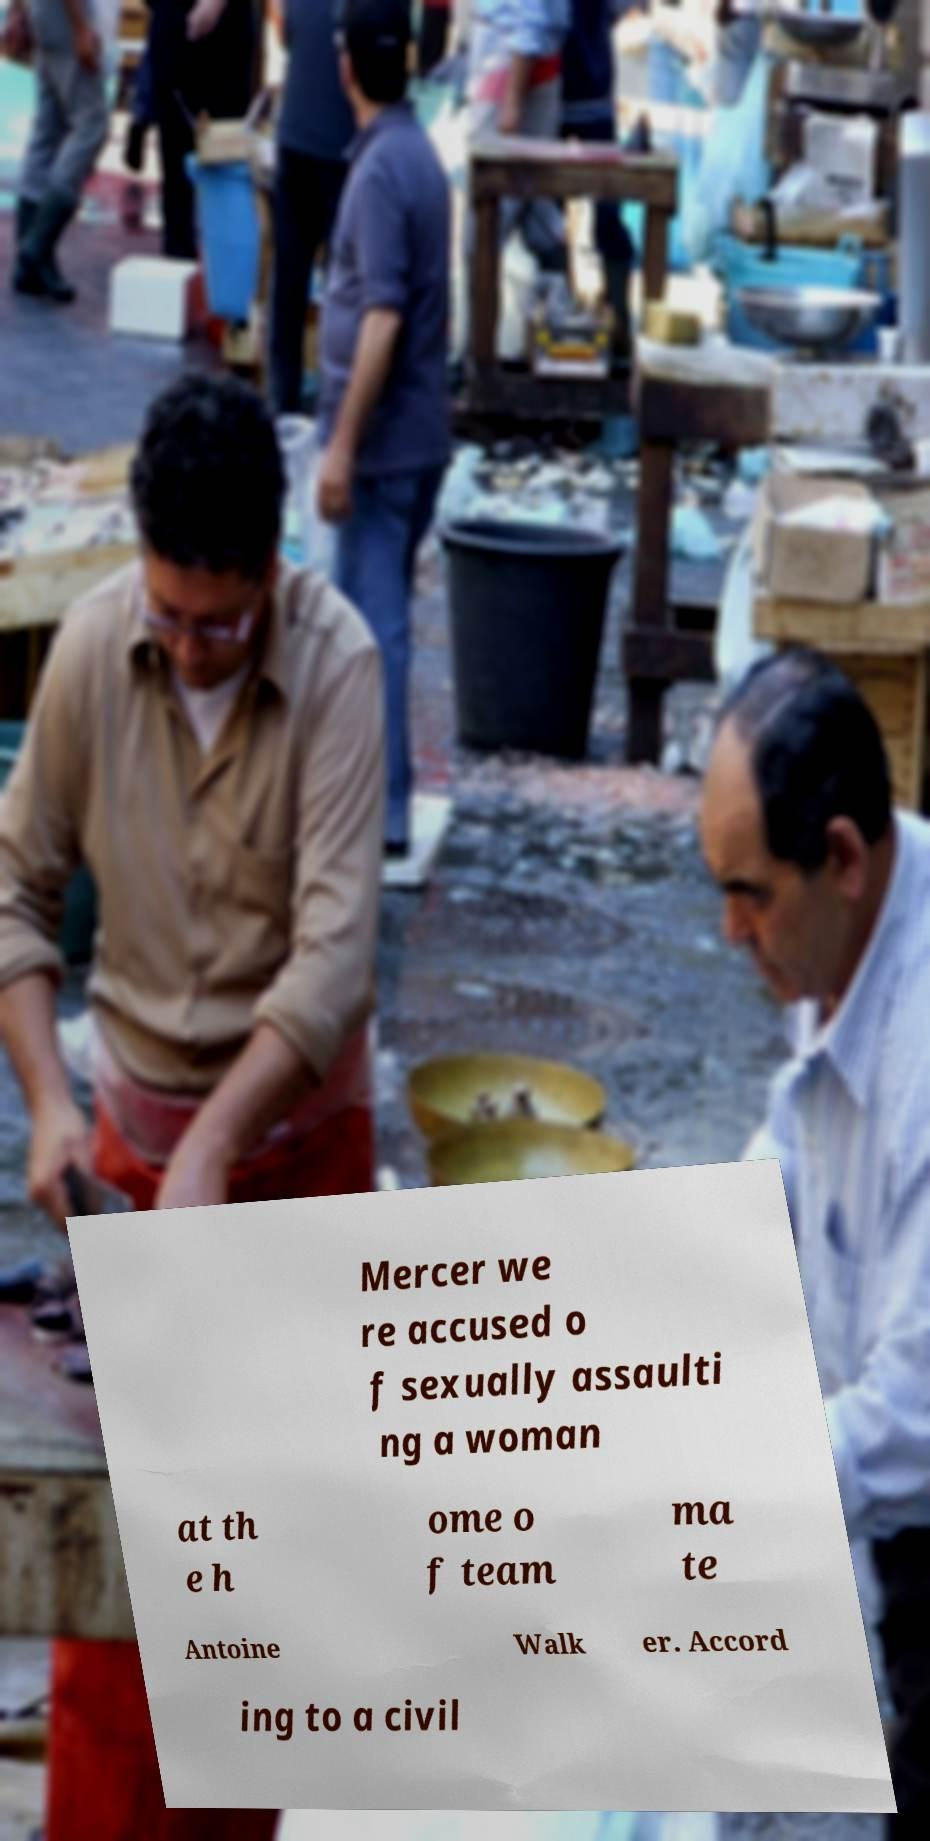Could you extract and type out the text from this image? Mercer we re accused o f sexually assaulti ng a woman at th e h ome o f team ma te Antoine Walk er. Accord ing to a civil 